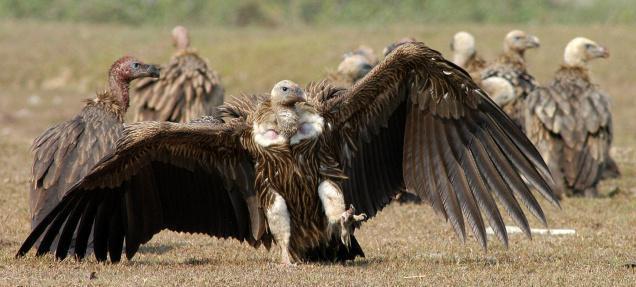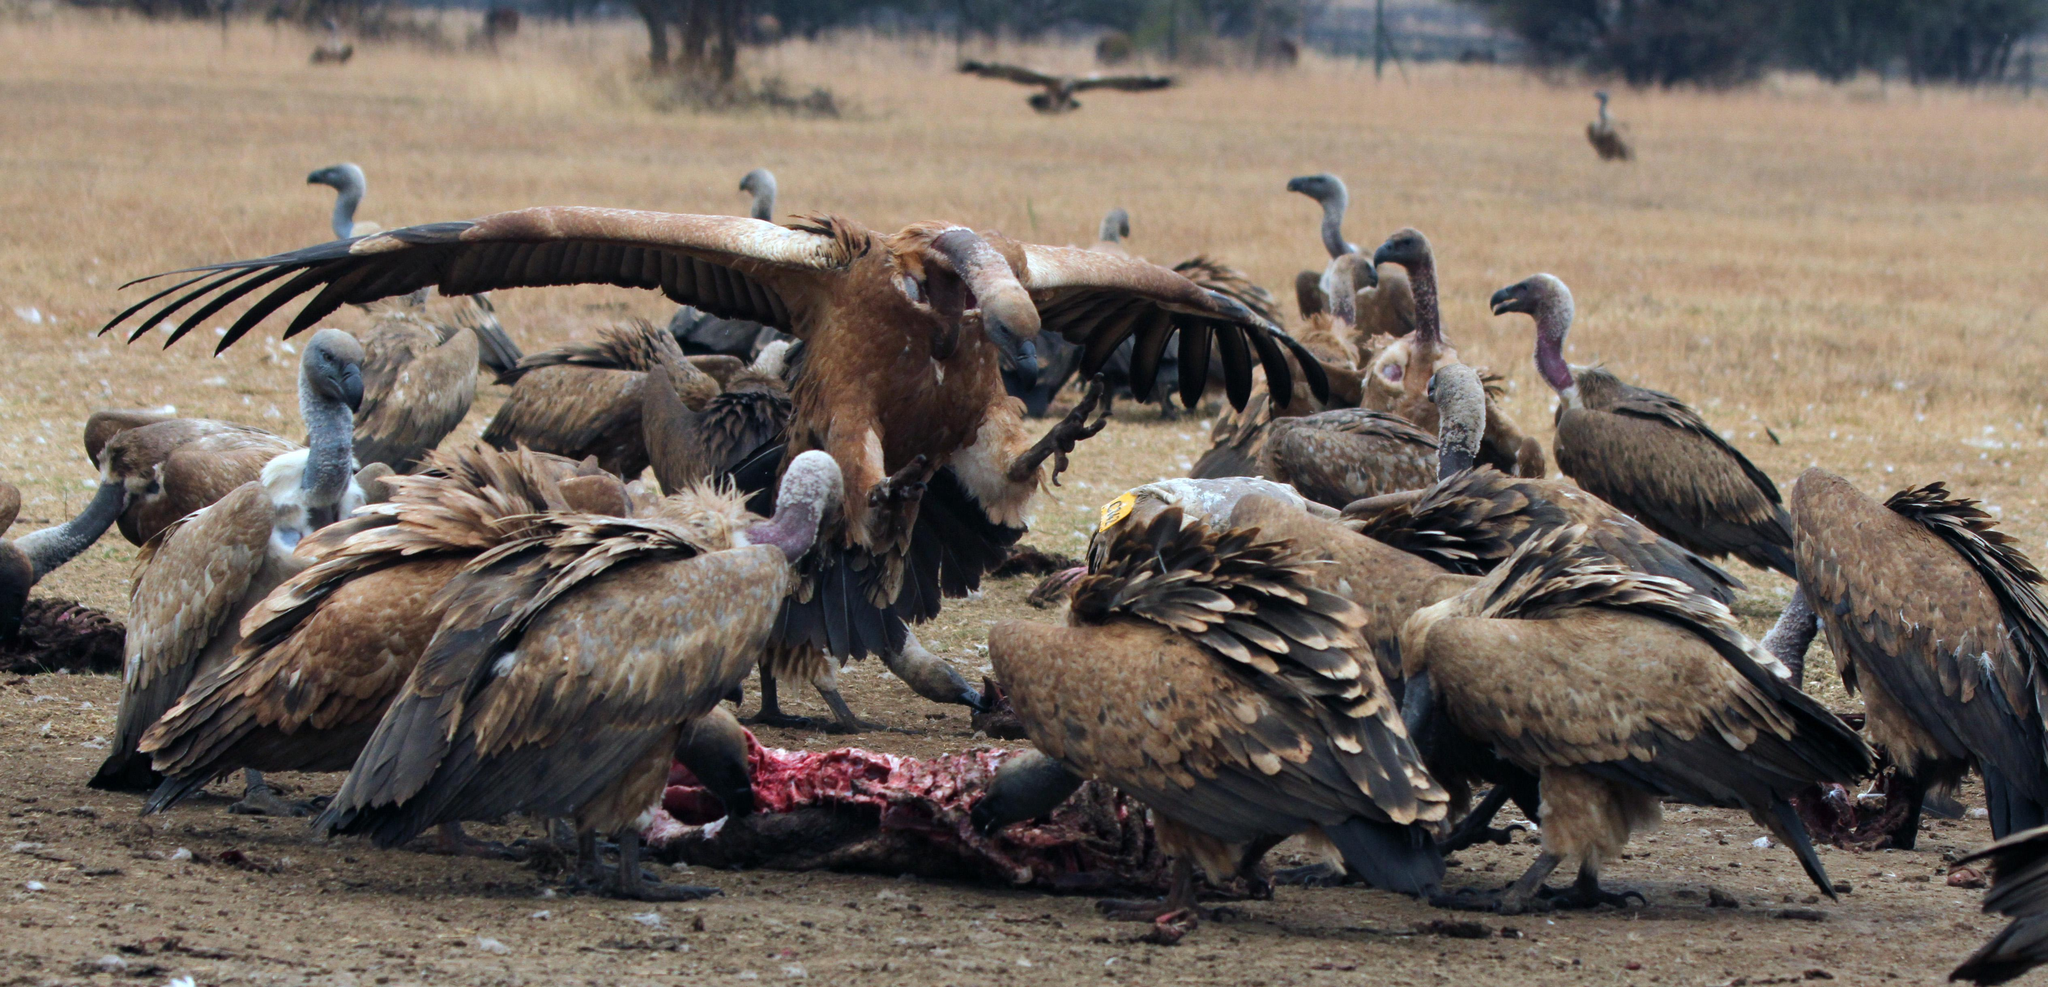The first image is the image on the left, the second image is the image on the right. Assess this claim about the two images: "there is at least one image with a vulture with wings spread". Correct or not? Answer yes or no. Yes. The first image is the image on the left, the second image is the image on the right. Analyze the images presented: Is the assertion "In the image to the left, vultures feed." valid? Answer yes or no. No. 